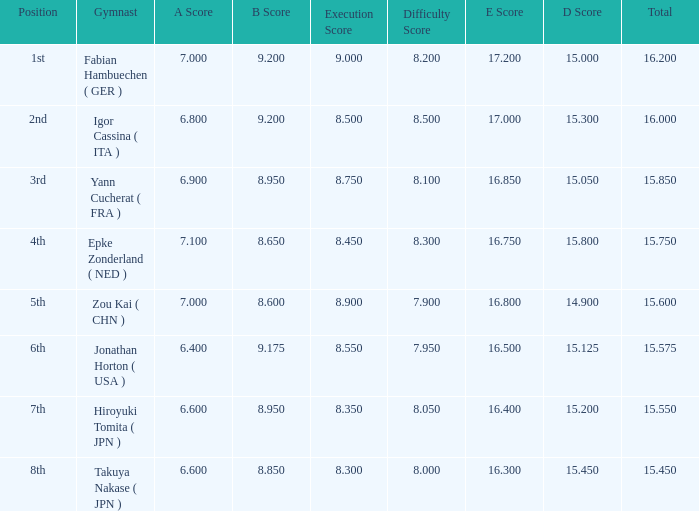Which gymnast had a b score of 8.95 and an a score less than 6.9 Hiroyuki Tomita ( JPN ). 